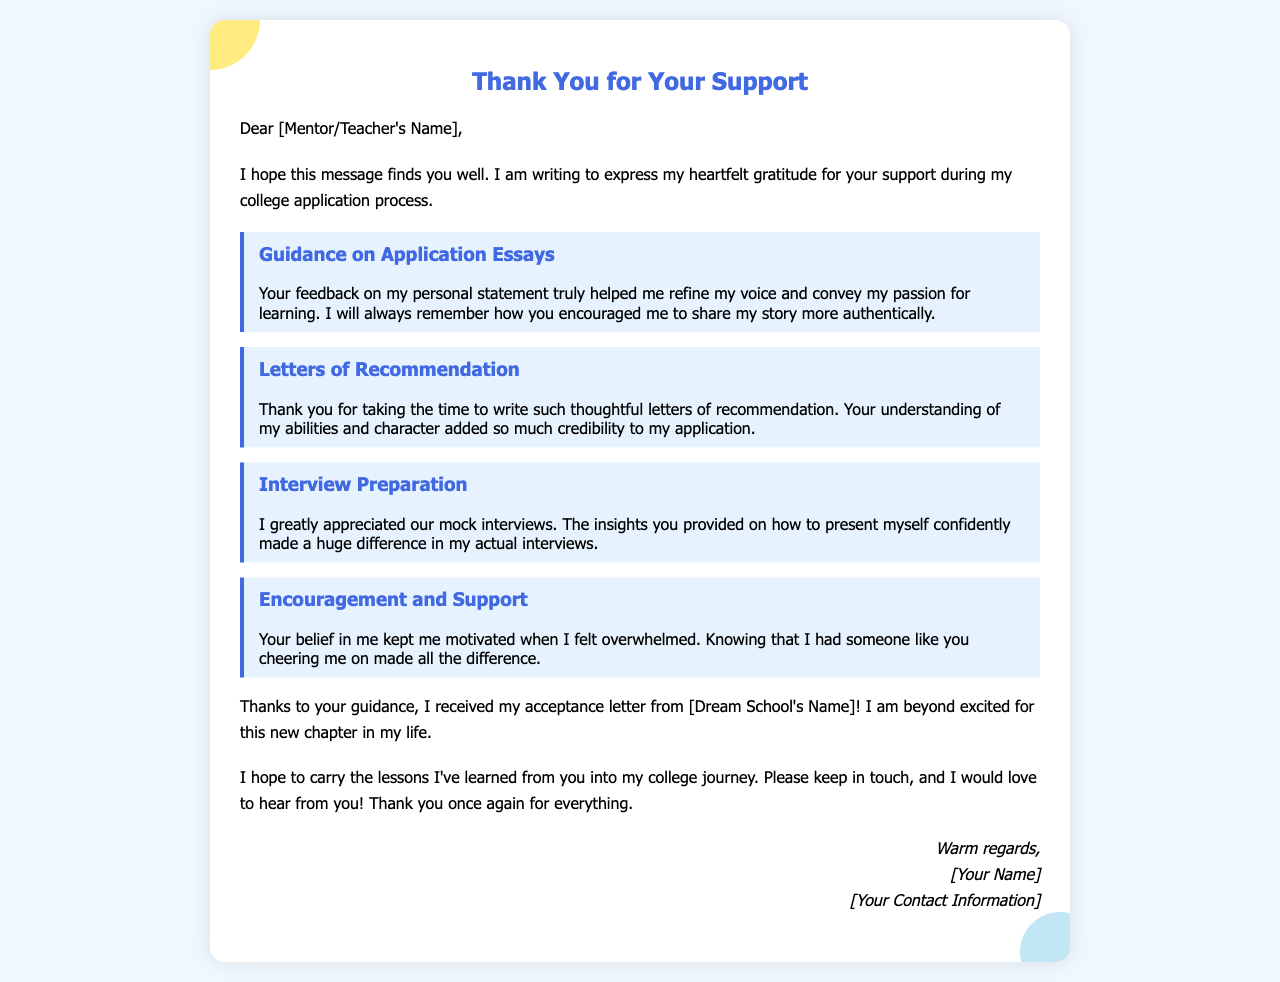What is the title of the letter? The title indicates the purpose of the document. The title is "Thank You for Your Support".
Answer: Thank You for Your Support Who is the letter addressed to? This identifies the recipient of the message. The letter is addressed to "[Mentor/Teacher's Name]".
Answer: [Mentor/Teacher's Name] What is mentioned as a key aspect of the mentor's support? This highlights a specific area of guidance provided. "Guidance on Application Essays" is mentioned as a key aspect.
Answer: Guidance on Application Essays What school did the author get accepted into? This reveals the recipient's success in the application process. The author mentions being accepted into "[Dream School's Name]".
Answer: [Dream School's Name] How many impact points are listed in the letter? The number of distinct support areas summarized in the document offers insight into the mentor's contributions. There are four impact points listed.
Answer: 4 What emotional effect did the mentor's support have on the author? This explores the personal emotional response and motivation derived from the mentor's support. The author expresses feeling "motivated" due to the mentor's belief in them.
Answer: motivated What is the author's closing remark? This indicates the author's final thoughts and sentiments at the end of the letter. The author says, "Thank you once again for everything."
Answer: Thank you once again for everything What is the author's sign-off salutation? This identifies how the author chooses to end the letter. The sign-off is "Warm regards,".
Answer: Warm regards, What type of document is this? This specifies the general category of the content presented in the letter. The document is a "thank-you letter".
Answer: thank-you letter 